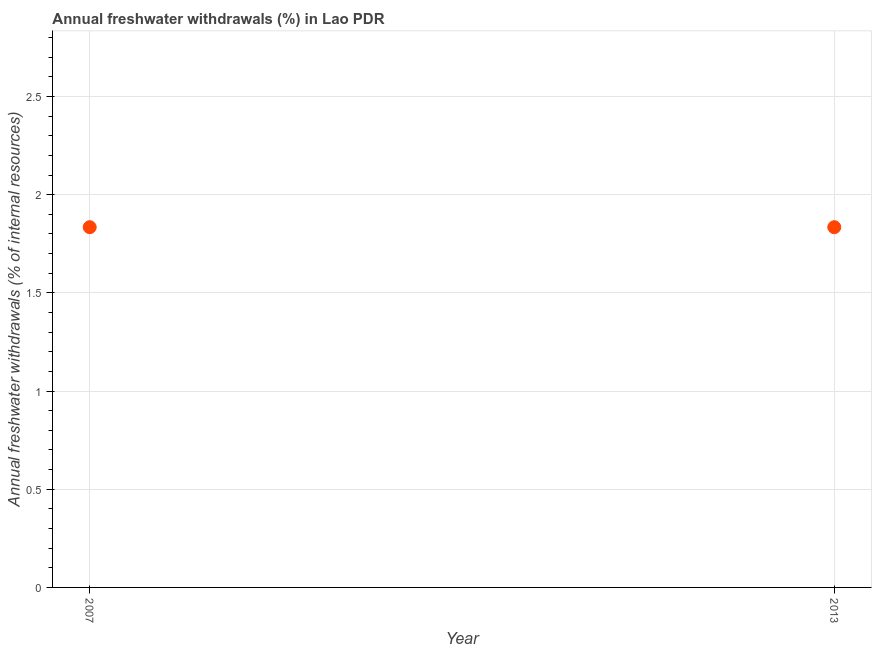What is the annual freshwater withdrawals in 2007?
Ensure brevity in your answer.  1.83. Across all years, what is the maximum annual freshwater withdrawals?
Provide a succinct answer. 1.83. Across all years, what is the minimum annual freshwater withdrawals?
Your response must be concise. 1.83. What is the sum of the annual freshwater withdrawals?
Provide a succinct answer. 3.67. What is the difference between the annual freshwater withdrawals in 2007 and 2013?
Give a very brief answer. 0. What is the average annual freshwater withdrawals per year?
Your answer should be very brief. 1.83. What is the median annual freshwater withdrawals?
Offer a very short reply. 1.83. In how many years, is the annual freshwater withdrawals greater than the average annual freshwater withdrawals taken over all years?
Offer a terse response. 0. What is the difference between two consecutive major ticks on the Y-axis?
Offer a very short reply. 0.5. Are the values on the major ticks of Y-axis written in scientific E-notation?
Your response must be concise. No. Does the graph contain any zero values?
Your response must be concise. No. What is the title of the graph?
Give a very brief answer. Annual freshwater withdrawals (%) in Lao PDR. What is the label or title of the X-axis?
Give a very brief answer. Year. What is the label or title of the Y-axis?
Your answer should be compact. Annual freshwater withdrawals (% of internal resources). What is the Annual freshwater withdrawals (% of internal resources) in 2007?
Make the answer very short. 1.83. What is the Annual freshwater withdrawals (% of internal resources) in 2013?
Ensure brevity in your answer.  1.83. What is the ratio of the Annual freshwater withdrawals (% of internal resources) in 2007 to that in 2013?
Keep it short and to the point. 1. 